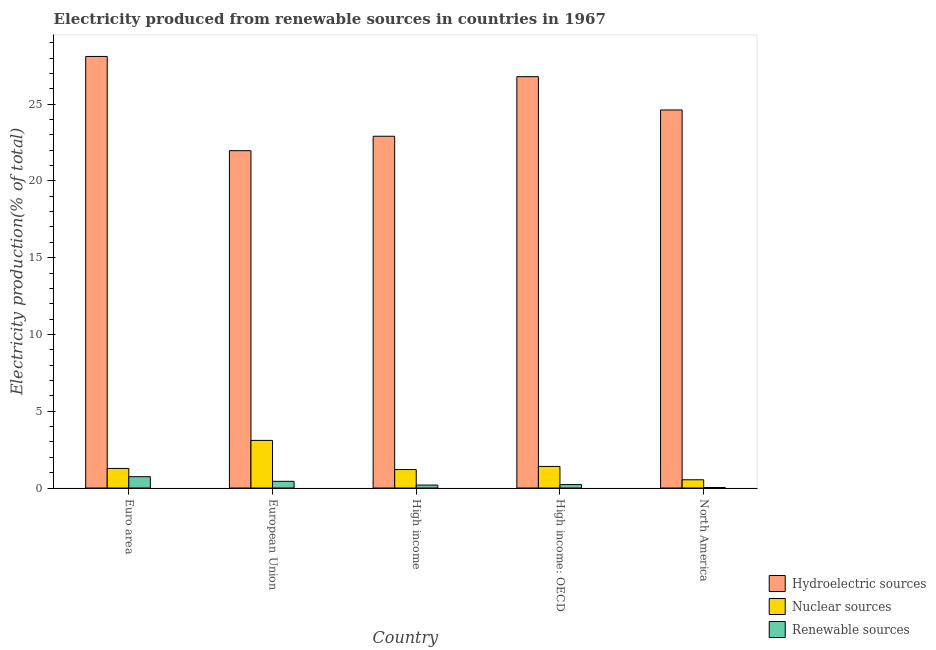How many bars are there on the 2nd tick from the left?
Offer a very short reply. 3. What is the percentage of electricity produced by nuclear sources in North America?
Your answer should be compact. 0.54. Across all countries, what is the maximum percentage of electricity produced by renewable sources?
Ensure brevity in your answer.  0.74. Across all countries, what is the minimum percentage of electricity produced by nuclear sources?
Offer a terse response. 0.54. In which country was the percentage of electricity produced by nuclear sources maximum?
Offer a terse response. European Union. In which country was the percentage of electricity produced by renewable sources minimum?
Make the answer very short. North America. What is the total percentage of electricity produced by renewable sources in the graph?
Your answer should be very brief. 1.62. What is the difference between the percentage of electricity produced by renewable sources in Euro area and that in High income?
Provide a short and direct response. 0.55. What is the difference between the percentage of electricity produced by nuclear sources in High income: OECD and the percentage of electricity produced by renewable sources in High income?
Your response must be concise. 1.21. What is the average percentage of electricity produced by hydroelectric sources per country?
Give a very brief answer. 24.88. What is the difference between the percentage of electricity produced by nuclear sources and percentage of electricity produced by renewable sources in High income: OECD?
Your response must be concise. 1.18. What is the ratio of the percentage of electricity produced by hydroelectric sources in Euro area to that in High income: OECD?
Your answer should be compact. 1.05. Is the difference between the percentage of electricity produced by hydroelectric sources in High income and High income: OECD greater than the difference between the percentage of electricity produced by renewable sources in High income and High income: OECD?
Your response must be concise. No. What is the difference between the highest and the second highest percentage of electricity produced by nuclear sources?
Provide a succinct answer. 1.69. What is the difference between the highest and the lowest percentage of electricity produced by renewable sources?
Ensure brevity in your answer.  0.7. In how many countries, is the percentage of electricity produced by renewable sources greater than the average percentage of electricity produced by renewable sources taken over all countries?
Give a very brief answer. 2. Is the sum of the percentage of electricity produced by renewable sources in Euro area and High income greater than the maximum percentage of electricity produced by nuclear sources across all countries?
Your answer should be very brief. No. What does the 3rd bar from the left in High income: OECD represents?
Offer a very short reply. Renewable sources. What does the 3rd bar from the right in High income represents?
Give a very brief answer. Hydroelectric sources. How many bars are there?
Offer a very short reply. 15. How many countries are there in the graph?
Provide a succinct answer. 5. What is the difference between two consecutive major ticks on the Y-axis?
Your response must be concise. 5. Does the graph contain grids?
Make the answer very short. No. Where does the legend appear in the graph?
Provide a short and direct response. Bottom right. What is the title of the graph?
Provide a succinct answer. Electricity produced from renewable sources in countries in 1967. Does "Ages 60+" appear as one of the legend labels in the graph?
Offer a very short reply. No. What is the label or title of the X-axis?
Give a very brief answer. Country. What is the label or title of the Y-axis?
Ensure brevity in your answer.  Electricity production(% of total). What is the Electricity production(% of total) of Hydroelectric sources in Euro area?
Your answer should be very brief. 28.1. What is the Electricity production(% of total) of Nuclear sources in Euro area?
Make the answer very short. 1.27. What is the Electricity production(% of total) in Renewable sources in Euro area?
Provide a succinct answer. 0.74. What is the Electricity production(% of total) in Hydroelectric sources in European Union?
Provide a short and direct response. 21.97. What is the Electricity production(% of total) of Nuclear sources in European Union?
Ensure brevity in your answer.  3.1. What is the Electricity production(% of total) in Renewable sources in European Union?
Your response must be concise. 0.44. What is the Electricity production(% of total) in Hydroelectric sources in High income?
Keep it short and to the point. 22.91. What is the Electricity production(% of total) of Nuclear sources in High income?
Offer a terse response. 1.2. What is the Electricity production(% of total) in Renewable sources in High income?
Your answer should be compact. 0.19. What is the Electricity production(% of total) in Hydroelectric sources in High income: OECD?
Give a very brief answer. 26.79. What is the Electricity production(% of total) in Nuclear sources in High income: OECD?
Ensure brevity in your answer.  1.4. What is the Electricity production(% of total) in Renewable sources in High income: OECD?
Provide a succinct answer. 0.22. What is the Electricity production(% of total) of Hydroelectric sources in North America?
Your response must be concise. 24.62. What is the Electricity production(% of total) in Nuclear sources in North America?
Offer a very short reply. 0.54. What is the Electricity production(% of total) in Renewable sources in North America?
Your response must be concise. 0.03. Across all countries, what is the maximum Electricity production(% of total) of Hydroelectric sources?
Your response must be concise. 28.1. Across all countries, what is the maximum Electricity production(% of total) of Nuclear sources?
Keep it short and to the point. 3.1. Across all countries, what is the maximum Electricity production(% of total) of Renewable sources?
Ensure brevity in your answer.  0.74. Across all countries, what is the minimum Electricity production(% of total) of Hydroelectric sources?
Provide a short and direct response. 21.97. Across all countries, what is the minimum Electricity production(% of total) in Nuclear sources?
Offer a very short reply. 0.54. Across all countries, what is the minimum Electricity production(% of total) of Renewable sources?
Keep it short and to the point. 0.03. What is the total Electricity production(% of total) in Hydroelectric sources in the graph?
Your answer should be compact. 124.38. What is the total Electricity production(% of total) of Nuclear sources in the graph?
Provide a short and direct response. 7.52. What is the total Electricity production(% of total) in Renewable sources in the graph?
Your answer should be very brief. 1.62. What is the difference between the Electricity production(% of total) of Hydroelectric sources in Euro area and that in European Union?
Ensure brevity in your answer.  6.14. What is the difference between the Electricity production(% of total) in Nuclear sources in Euro area and that in European Union?
Keep it short and to the point. -1.83. What is the difference between the Electricity production(% of total) in Renewable sources in Euro area and that in European Union?
Provide a succinct answer. 0.3. What is the difference between the Electricity production(% of total) of Hydroelectric sources in Euro area and that in High income?
Your response must be concise. 5.2. What is the difference between the Electricity production(% of total) in Nuclear sources in Euro area and that in High income?
Offer a terse response. 0.07. What is the difference between the Electricity production(% of total) in Renewable sources in Euro area and that in High income?
Your answer should be compact. 0.55. What is the difference between the Electricity production(% of total) of Hydroelectric sources in Euro area and that in High income: OECD?
Provide a short and direct response. 1.32. What is the difference between the Electricity production(% of total) in Nuclear sources in Euro area and that in High income: OECD?
Your answer should be very brief. -0.13. What is the difference between the Electricity production(% of total) of Renewable sources in Euro area and that in High income: OECD?
Provide a short and direct response. 0.51. What is the difference between the Electricity production(% of total) of Hydroelectric sources in Euro area and that in North America?
Your answer should be compact. 3.49. What is the difference between the Electricity production(% of total) of Nuclear sources in Euro area and that in North America?
Give a very brief answer. 0.74. What is the difference between the Electricity production(% of total) of Renewable sources in Euro area and that in North America?
Make the answer very short. 0.7. What is the difference between the Electricity production(% of total) of Hydroelectric sources in European Union and that in High income?
Offer a very short reply. -0.94. What is the difference between the Electricity production(% of total) in Nuclear sources in European Union and that in High income?
Keep it short and to the point. 1.9. What is the difference between the Electricity production(% of total) in Renewable sources in European Union and that in High income?
Keep it short and to the point. 0.24. What is the difference between the Electricity production(% of total) in Hydroelectric sources in European Union and that in High income: OECD?
Ensure brevity in your answer.  -4.82. What is the difference between the Electricity production(% of total) in Nuclear sources in European Union and that in High income: OECD?
Keep it short and to the point. 1.69. What is the difference between the Electricity production(% of total) of Renewable sources in European Union and that in High income: OECD?
Give a very brief answer. 0.21. What is the difference between the Electricity production(% of total) of Hydroelectric sources in European Union and that in North America?
Your answer should be compact. -2.65. What is the difference between the Electricity production(% of total) of Nuclear sources in European Union and that in North America?
Keep it short and to the point. 2.56. What is the difference between the Electricity production(% of total) in Renewable sources in European Union and that in North America?
Your response must be concise. 0.4. What is the difference between the Electricity production(% of total) in Hydroelectric sources in High income and that in High income: OECD?
Provide a succinct answer. -3.88. What is the difference between the Electricity production(% of total) of Nuclear sources in High income and that in High income: OECD?
Provide a succinct answer. -0.2. What is the difference between the Electricity production(% of total) of Renewable sources in High income and that in High income: OECD?
Ensure brevity in your answer.  -0.03. What is the difference between the Electricity production(% of total) of Hydroelectric sources in High income and that in North America?
Ensure brevity in your answer.  -1.71. What is the difference between the Electricity production(% of total) of Nuclear sources in High income and that in North America?
Ensure brevity in your answer.  0.67. What is the difference between the Electricity production(% of total) in Renewable sources in High income and that in North America?
Your answer should be compact. 0.16. What is the difference between the Electricity production(% of total) of Hydroelectric sources in High income: OECD and that in North America?
Ensure brevity in your answer.  2.17. What is the difference between the Electricity production(% of total) in Nuclear sources in High income: OECD and that in North America?
Make the answer very short. 0.87. What is the difference between the Electricity production(% of total) in Renewable sources in High income: OECD and that in North America?
Ensure brevity in your answer.  0.19. What is the difference between the Electricity production(% of total) in Hydroelectric sources in Euro area and the Electricity production(% of total) in Nuclear sources in European Union?
Offer a terse response. 25. What is the difference between the Electricity production(% of total) of Hydroelectric sources in Euro area and the Electricity production(% of total) of Renewable sources in European Union?
Give a very brief answer. 27.67. What is the difference between the Electricity production(% of total) of Nuclear sources in Euro area and the Electricity production(% of total) of Renewable sources in European Union?
Make the answer very short. 0.84. What is the difference between the Electricity production(% of total) of Hydroelectric sources in Euro area and the Electricity production(% of total) of Nuclear sources in High income?
Give a very brief answer. 26.9. What is the difference between the Electricity production(% of total) of Hydroelectric sources in Euro area and the Electricity production(% of total) of Renewable sources in High income?
Keep it short and to the point. 27.91. What is the difference between the Electricity production(% of total) in Nuclear sources in Euro area and the Electricity production(% of total) in Renewable sources in High income?
Your response must be concise. 1.08. What is the difference between the Electricity production(% of total) in Hydroelectric sources in Euro area and the Electricity production(% of total) in Nuclear sources in High income: OECD?
Give a very brief answer. 26.7. What is the difference between the Electricity production(% of total) in Hydroelectric sources in Euro area and the Electricity production(% of total) in Renewable sources in High income: OECD?
Give a very brief answer. 27.88. What is the difference between the Electricity production(% of total) in Nuclear sources in Euro area and the Electricity production(% of total) in Renewable sources in High income: OECD?
Make the answer very short. 1.05. What is the difference between the Electricity production(% of total) in Hydroelectric sources in Euro area and the Electricity production(% of total) in Nuclear sources in North America?
Your answer should be compact. 27.57. What is the difference between the Electricity production(% of total) in Hydroelectric sources in Euro area and the Electricity production(% of total) in Renewable sources in North America?
Keep it short and to the point. 28.07. What is the difference between the Electricity production(% of total) of Nuclear sources in Euro area and the Electricity production(% of total) of Renewable sources in North America?
Make the answer very short. 1.24. What is the difference between the Electricity production(% of total) of Hydroelectric sources in European Union and the Electricity production(% of total) of Nuclear sources in High income?
Your answer should be compact. 20.77. What is the difference between the Electricity production(% of total) of Hydroelectric sources in European Union and the Electricity production(% of total) of Renewable sources in High income?
Give a very brief answer. 21.78. What is the difference between the Electricity production(% of total) in Nuclear sources in European Union and the Electricity production(% of total) in Renewable sources in High income?
Your response must be concise. 2.91. What is the difference between the Electricity production(% of total) of Hydroelectric sources in European Union and the Electricity production(% of total) of Nuclear sources in High income: OECD?
Provide a succinct answer. 20.56. What is the difference between the Electricity production(% of total) in Hydroelectric sources in European Union and the Electricity production(% of total) in Renewable sources in High income: OECD?
Keep it short and to the point. 21.74. What is the difference between the Electricity production(% of total) in Nuclear sources in European Union and the Electricity production(% of total) in Renewable sources in High income: OECD?
Keep it short and to the point. 2.88. What is the difference between the Electricity production(% of total) in Hydroelectric sources in European Union and the Electricity production(% of total) in Nuclear sources in North America?
Make the answer very short. 21.43. What is the difference between the Electricity production(% of total) of Hydroelectric sources in European Union and the Electricity production(% of total) of Renewable sources in North America?
Your response must be concise. 21.93. What is the difference between the Electricity production(% of total) of Nuclear sources in European Union and the Electricity production(% of total) of Renewable sources in North America?
Offer a terse response. 3.07. What is the difference between the Electricity production(% of total) in Hydroelectric sources in High income and the Electricity production(% of total) in Nuclear sources in High income: OECD?
Give a very brief answer. 21.5. What is the difference between the Electricity production(% of total) in Hydroelectric sources in High income and the Electricity production(% of total) in Renewable sources in High income: OECD?
Ensure brevity in your answer.  22.68. What is the difference between the Electricity production(% of total) in Nuclear sources in High income and the Electricity production(% of total) in Renewable sources in High income: OECD?
Provide a succinct answer. 0.98. What is the difference between the Electricity production(% of total) of Hydroelectric sources in High income and the Electricity production(% of total) of Nuclear sources in North America?
Ensure brevity in your answer.  22.37. What is the difference between the Electricity production(% of total) in Hydroelectric sources in High income and the Electricity production(% of total) in Renewable sources in North America?
Give a very brief answer. 22.87. What is the difference between the Electricity production(% of total) in Nuclear sources in High income and the Electricity production(% of total) in Renewable sources in North America?
Your answer should be very brief. 1.17. What is the difference between the Electricity production(% of total) in Hydroelectric sources in High income: OECD and the Electricity production(% of total) in Nuclear sources in North America?
Your response must be concise. 26.25. What is the difference between the Electricity production(% of total) in Hydroelectric sources in High income: OECD and the Electricity production(% of total) in Renewable sources in North America?
Provide a short and direct response. 26.75. What is the difference between the Electricity production(% of total) of Nuclear sources in High income: OECD and the Electricity production(% of total) of Renewable sources in North America?
Offer a very short reply. 1.37. What is the average Electricity production(% of total) in Hydroelectric sources per country?
Your response must be concise. 24.88. What is the average Electricity production(% of total) in Nuclear sources per country?
Ensure brevity in your answer.  1.5. What is the average Electricity production(% of total) in Renewable sources per country?
Provide a short and direct response. 0.32. What is the difference between the Electricity production(% of total) of Hydroelectric sources and Electricity production(% of total) of Nuclear sources in Euro area?
Offer a terse response. 26.83. What is the difference between the Electricity production(% of total) in Hydroelectric sources and Electricity production(% of total) in Renewable sources in Euro area?
Make the answer very short. 27.37. What is the difference between the Electricity production(% of total) of Nuclear sources and Electricity production(% of total) of Renewable sources in Euro area?
Your answer should be compact. 0.54. What is the difference between the Electricity production(% of total) of Hydroelectric sources and Electricity production(% of total) of Nuclear sources in European Union?
Your answer should be very brief. 18.87. What is the difference between the Electricity production(% of total) in Hydroelectric sources and Electricity production(% of total) in Renewable sources in European Union?
Offer a very short reply. 21.53. What is the difference between the Electricity production(% of total) of Nuclear sources and Electricity production(% of total) of Renewable sources in European Union?
Provide a succinct answer. 2.66. What is the difference between the Electricity production(% of total) of Hydroelectric sources and Electricity production(% of total) of Nuclear sources in High income?
Keep it short and to the point. 21.71. What is the difference between the Electricity production(% of total) in Hydroelectric sources and Electricity production(% of total) in Renewable sources in High income?
Offer a very short reply. 22.72. What is the difference between the Electricity production(% of total) in Nuclear sources and Electricity production(% of total) in Renewable sources in High income?
Offer a terse response. 1.01. What is the difference between the Electricity production(% of total) of Hydroelectric sources and Electricity production(% of total) of Nuclear sources in High income: OECD?
Provide a short and direct response. 25.38. What is the difference between the Electricity production(% of total) in Hydroelectric sources and Electricity production(% of total) in Renewable sources in High income: OECD?
Give a very brief answer. 26.56. What is the difference between the Electricity production(% of total) of Nuclear sources and Electricity production(% of total) of Renewable sources in High income: OECD?
Keep it short and to the point. 1.18. What is the difference between the Electricity production(% of total) in Hydroelectric sources and Electricity production(% of total) in Nuclear sources in North America?
Your answer should be very brief. 24.08. What is the difference between the Electricity production(% of total) in Hydroelectric sources and Electricity production(% of total) in Renewable sources in North America?
Offer a very short reply. 24.59. What is the difference between the Electricity production(% of total) of Nuclear sources and Electricity production(% of total) of Renewable sources in North America?
Provide a succinct answer. 0.5. What is the ratio of the Electricity production(% of total) in Hydroelectric sources in Euro area to that in European Union?
Make the answer very short. 1.28. What is the ratio of the Electricity production(% of total) of Nuclear sources in Euro area to that in European Union?
Your answer should be very brief. 0.41. What is the ratio of the Electricity production(% of total) of Renewable sources in Euro area to that in European Union?
Offer a very short reply. 1.69. What is the ratio of the Electricity production(% of total) in Hydroelectric sources in Euro area to that in High income?
Provide a succinct answer. 1.23. What is the ratio of the Electricity production(% of total) in Nuclear sources in Euro area to that in High income?
Offer a very short reply. 1.06. What is the ratio of the Electricity production(% of total) of Renewable sources in Euro area to that in High income?
Your answer should be compact. 3.86. What is the ratio of the Electricity production(% of total) in Hydroelectric sources in Euro area to that in High income: OECD?
Your answer should be compact. 1.05. What is the ratio of the Electricity production(% of total) of Nuclear sources in Euro area to that in High income: OECD?
Your answer should be very brief. 0.91. What is the ratio of the Electricity production(% of total) of Renewable sources in Euro area to that in High income: OECD?
Your answer should be very brief. 3.3. What is the ratio of the Electricity production(% of total) in Hydroelectric sources in Euro area to that in North America?
Keep it short and to the point. 1.14. What is the ratio of the Electricity production(% of total) in Nuclear sources in Euro area to that in North America?
Offer a very short reply. 2.38. What is the ratio of the Electricity production(% of total) in Renewable sources in Euro area to that in North America?
Provide a succinct answer. 22.61. What is the ratio of the Electricity production(% of total) of Nuclear sources in European Union to that in High income?
Make the answer very short. 2.58. What is the ratio of the Electricity production(% of total) in Renewable sources in European Union to that in High income?
Provide a succinct answer. 2.28. What is the ratio of the Electricity production(% of total) in Hydroelectric sources in European Union to that in High income: OECD?
Make the answer very short. 0.82. What is the ratio of the Electricity production(% of total) of Nuclear sources in European Union to that in High income: OECD?
Your response must be concise. 2.21. What is the ratio of the Electricity production(% of total) of Renewable sources in European Union to that in High income: OECD?
Offer a very short reply. 1.95. What is the ratio of the Electricity production(% of total) of Hydroelectric sources in European Union to that in North America?
Give a very brief answer. 0.89. What is the ratio of the Electricity production(% of total) in Nuclear sources in European Union to that in North America?
Make the answer very short. 5.78. What is the ratio of the Electricity production(% of total) in Renewable sources in European Union to that in North America?
Your response must be concise. 13.37. What is the ratio of the Electricity production(% of total) in Hydroelectric sources in High income to that in High income: OECD?
Offer a very short reply. 0.86. What is the ratio of the Electricity production(% of total) of Nuclear sources in High income to that in High income: OECD?
Provide a short and direct response. 0.86. What is the ratio of the Electricity production(% of total) in Renewable sources in High income to that in High income: OECD?
Provide a short and direct response. 0.86. What is the ratio of the Electricity production(% of total) in Hydroelectric sources in High income to that in North America?
Provide a short and direct response. 0.93. What is the ratio of the Electricity production(% of total) of Nuclear sources in High income to that in North America?
Make the answer very short. 2.24. What is the ratio of the Electricity production(% of total) in Renewable sources in High income to that in North America?
Your response must be concise. 5.86. What is the ratio of the Electricity production(% of total) of Hydroelectric sources in High income: OECD to that in North America?
Offer a very short reply. 1.09. What is the ratio of the Electricity production(% of total) of Nuclear sources in High income: OECD to that in North America?
Make the answer very short. 2.62. What is the ratio of the Electricity production(% of total) of Renewable sources in High income: OECD to that in North America?
Give a very brief answer. 6.85. What is the difference between the highest and the second highest Electricity production(% of total) in Hydroelectric sources?
Your response must be concise. 1.32. What is the difference between the highest and the second highest Electricity production(% of total) in Nuclear sources?
Provide a short and direct response. 1.69. What is the difference between the highest and the second highest Electricity production(% of total) in Renewable sources?
Provide a short and direct response. 0.3. What is the difference between the highest and the lowest Electricity production(% of total) of Hydroelectric sources?
Your answer should be compact. 6.14. What is the difference between the highest and the lowest Electricity production(% of total) of Nuclear sources?
Give a very brief answer. 2.56. What is the difference between the highest and the lowest Electricity production(% of total) in Renewable sources?
Your answer should be compact. 0.7. 